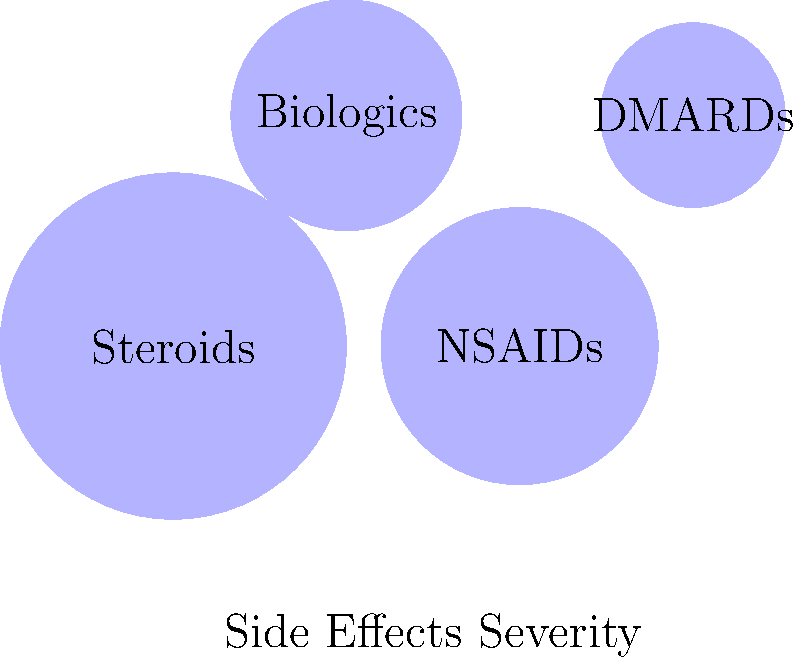Based on the bubble chart comparing side effects of various treatment options for chronic health issues, which medication appears to have the most severe and frequent side effects? To answer this question, we need to analyze the bubble chart:

1. The chart shows four treatment options: Steroids, NSAIDs, Biologics, and DMARDs.
2. The size of each bubble represents the severity of side effects.
3. The position on the y-axis represents the frequency of side effects.
4. The position on the x-axis doesn't seem to represent any specific variable.

Analyzing each option:
1. Steroids: Largest bubble, positioned lowest on the y-axis.
2. NSAIDs: Second largest bubble, also positioned low on the y-axis.
3. Biologics: Third largest bubble, positioned higher on the y-axis than Steroids and NSAIDs.
4. DMARDs: Smallest bubble, positioned highest on the y-axis.

The Steroids bubble is the largest, indicating the most severe side effects. It's also positioned low on the y-axis, suggesting these severe side effects occur frequently.

Therefore, based on the information provided in the bubble chart, Steroids appear to have the most severe and frequent side effects among the treatment options shown.
Answer: Steroids 